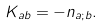Convert formula to latex. <formula><loc_0><loc_0><loc_500><loc_500>K _ { a b } = - n _ { a ; b } .</formula> 